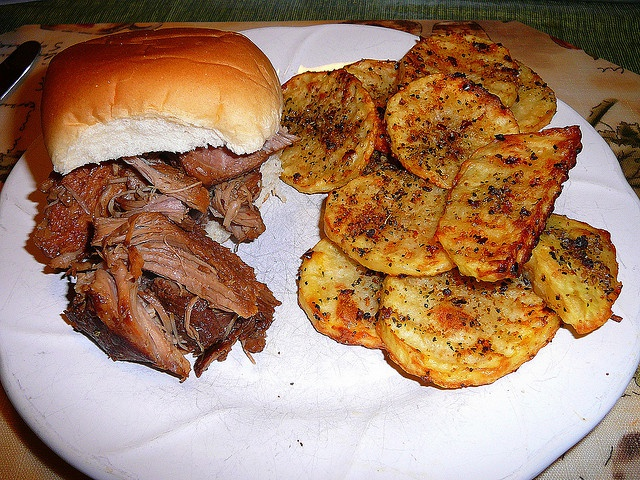Describe the objects in this image and their specific colors. I can see sandwich in black, maroon, brown, and tan tones, dining table in black, maroon, and gray tones, sandwich in black, orange, tan, and red tones, sandwich in black, red, maroon, and orange tones, and sandwich in black, olive, and maroon tones in this image. 